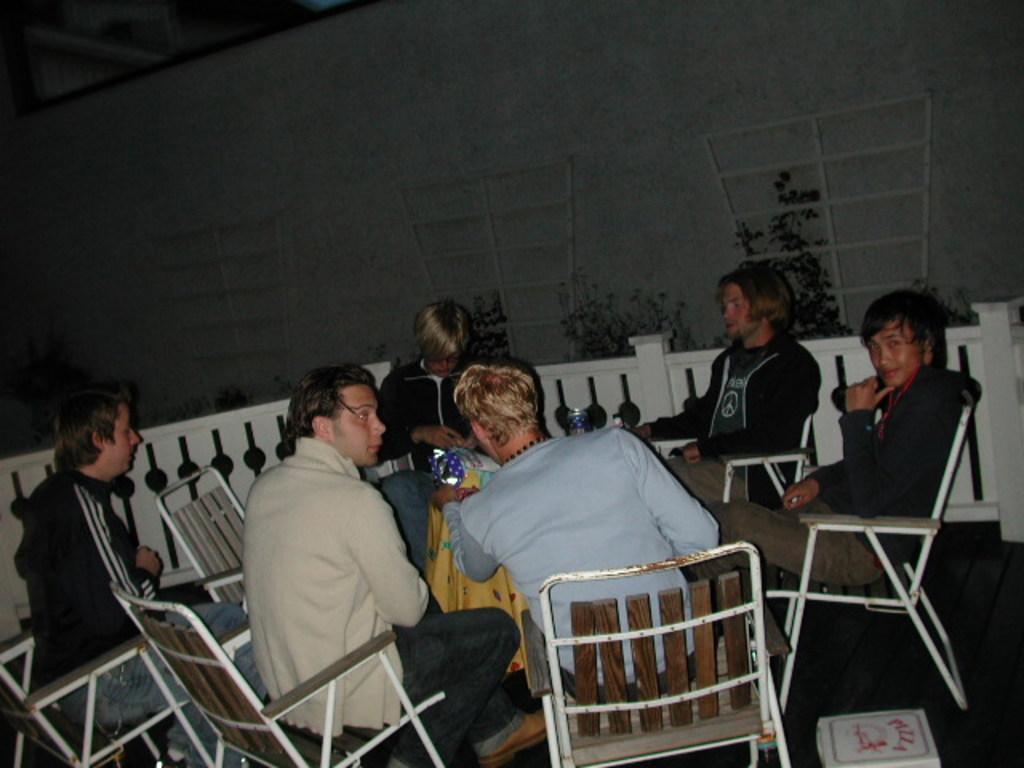Could you give a brief overview of what you see in this image? In this image there are some boys those who are sitting around the table on the chairs, there are some bottles on the table, there care some trees around the are of the image. 